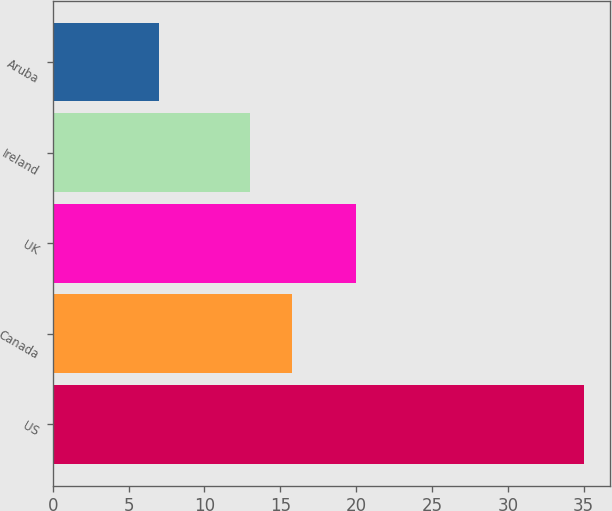Convert chart. <chart><loc_0><loc_0><loc_500><loc_500><bar_chart><fcel>US<fcel>Canada<fcel>UK<fcel>Ireland<fcel>Aruba<nl><fcel>35<fcel>15.8<fcel>20<fcel>13<fcel>7<nl></chart> 